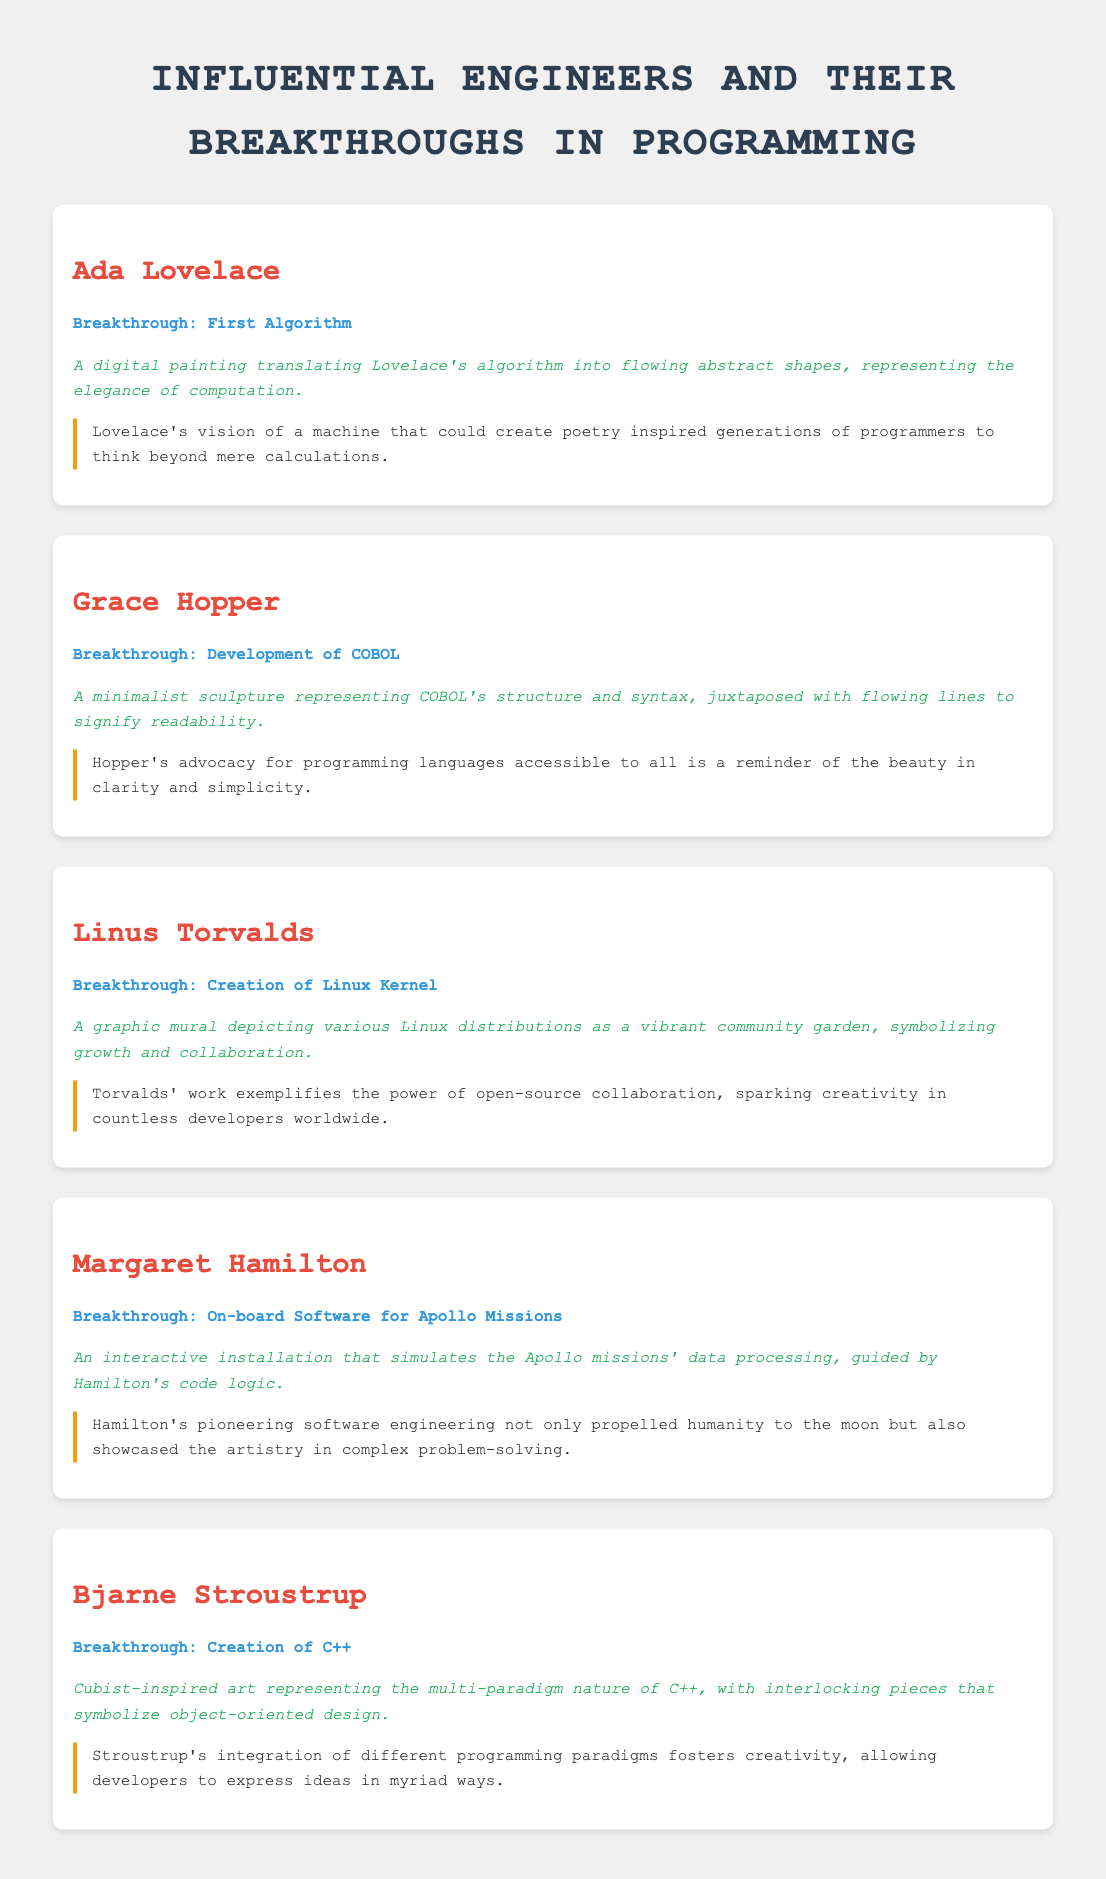What is the breakthrough attributed to Ada Lovelace? Ada Lovelace's breakthrough is noted as the first algorithm.
Answer: First Algorithm What artistic reinterpretation is associated with Grace Hopper? The artistic reinterpretation for Grace Hopper is a minimalist sculpture representing COBOL's structure and syntax.
Answer: Minimalist sculpture Which engineer created the Linux Kernel? The engineer who created the Linux Kernel is Linus Torvalds.
Answer: Linus Torvalds What type of installation is inspired by Margaret Hamilton's work? An interactive installation simulates Apollo missions' data processing, inspired by Hamilton's code logic.
Answer: Interactive installation What programming language did Bjarne Stroustrup create? Bjarne Stroustrup created the programming language C++.
Answer: C++ What color is used for the engineer's name headers? The color used for the engineer's name headers is #e74c3c.
Answer: #e74c3c Which engineer's work highlights the beauty in clarity and simplicity? Grace Hopper's work highlights the beauty in clarity and simplicity.
Answer: Grace Hopper How many engineers are featured in the document? The document features five engineers.
Answer: Five What visual element is used in Linus Torvalds' artistic reinterpretation? A graphic mural is used to depict Linux distributions as a vibrant community garden.
Answer: Graphic mural 